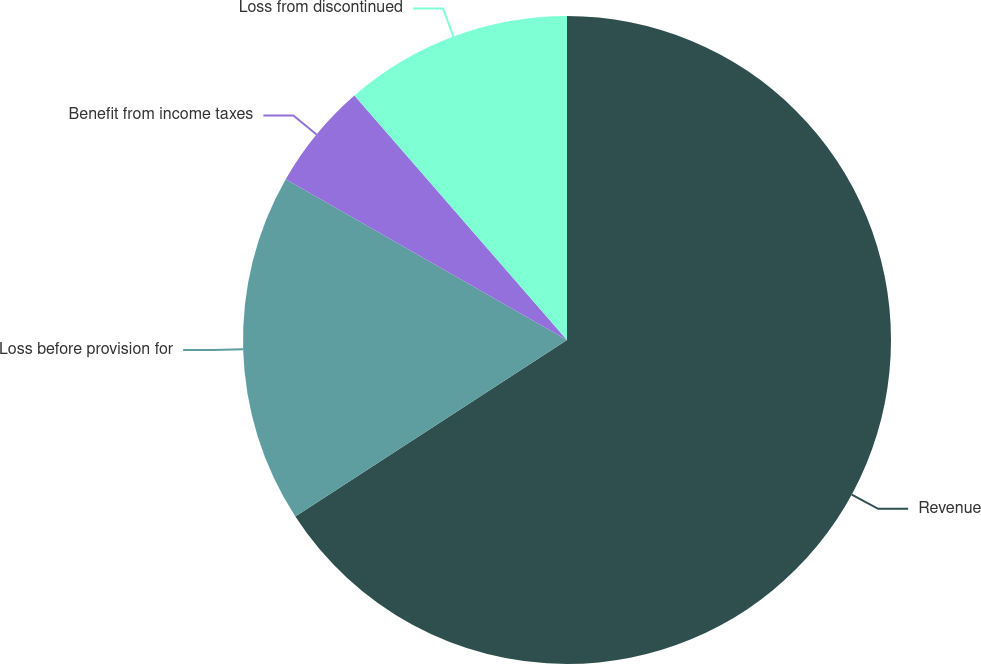Convert chart. <chart><loc_0><loc_0><loc_500><loc_500><pie_chart><fcel>Revenue<fcel>Loss before provision for<fcel>Benefit from income taxes<fcel>Loss from discontinued<nl><fcel>65.82%<fcel>17.44%<fcel>5.34%<fcel>11.39%<nl></chart> 